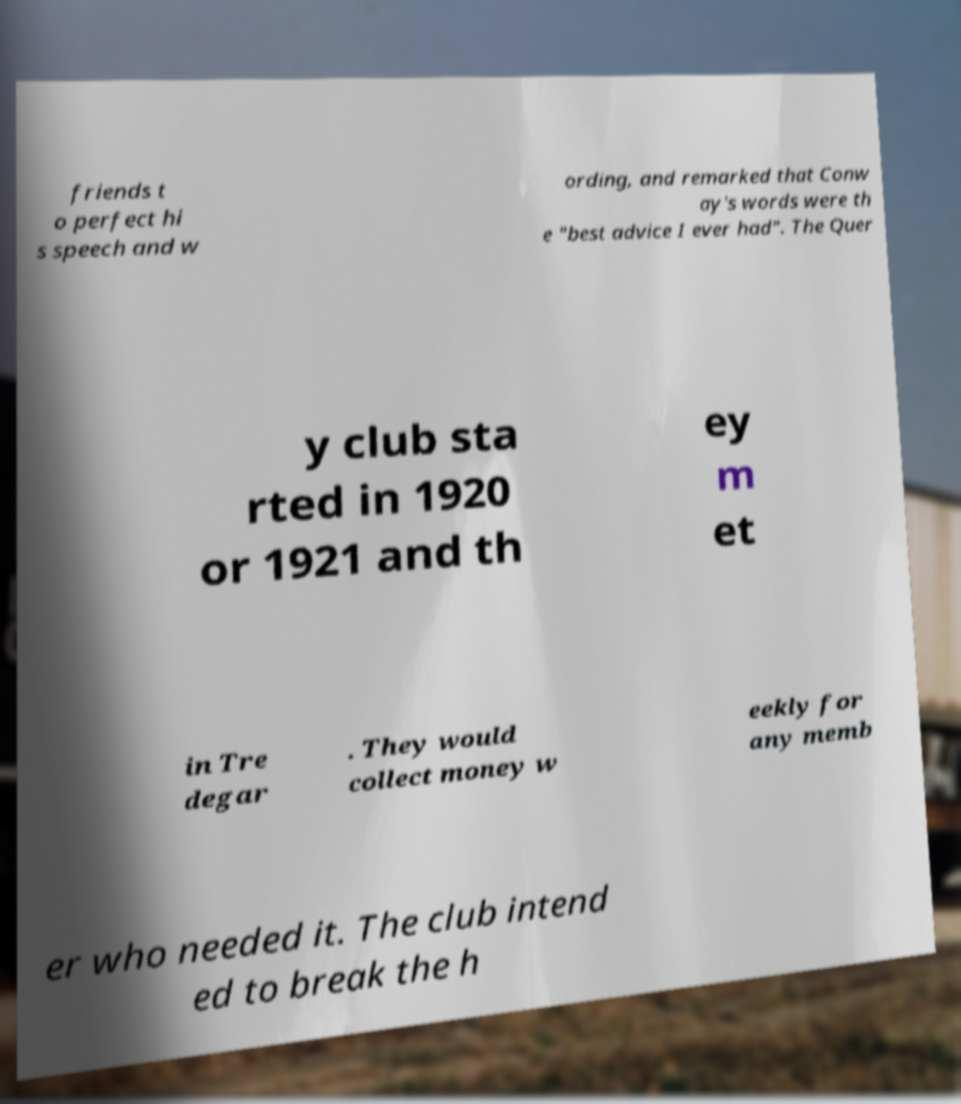What messages or text are displayed in this image? I need them in a readable, typed format. friends t o perfect hi s speech and w ording, and remarked that Conw ay's words were th e "best advice I ever had". The Quer y club sta rted in 1920 or 1921 and th ey m et in Tre degar . They would collect money w eekly for any memb er who needed it. The club intend ed to break the h 